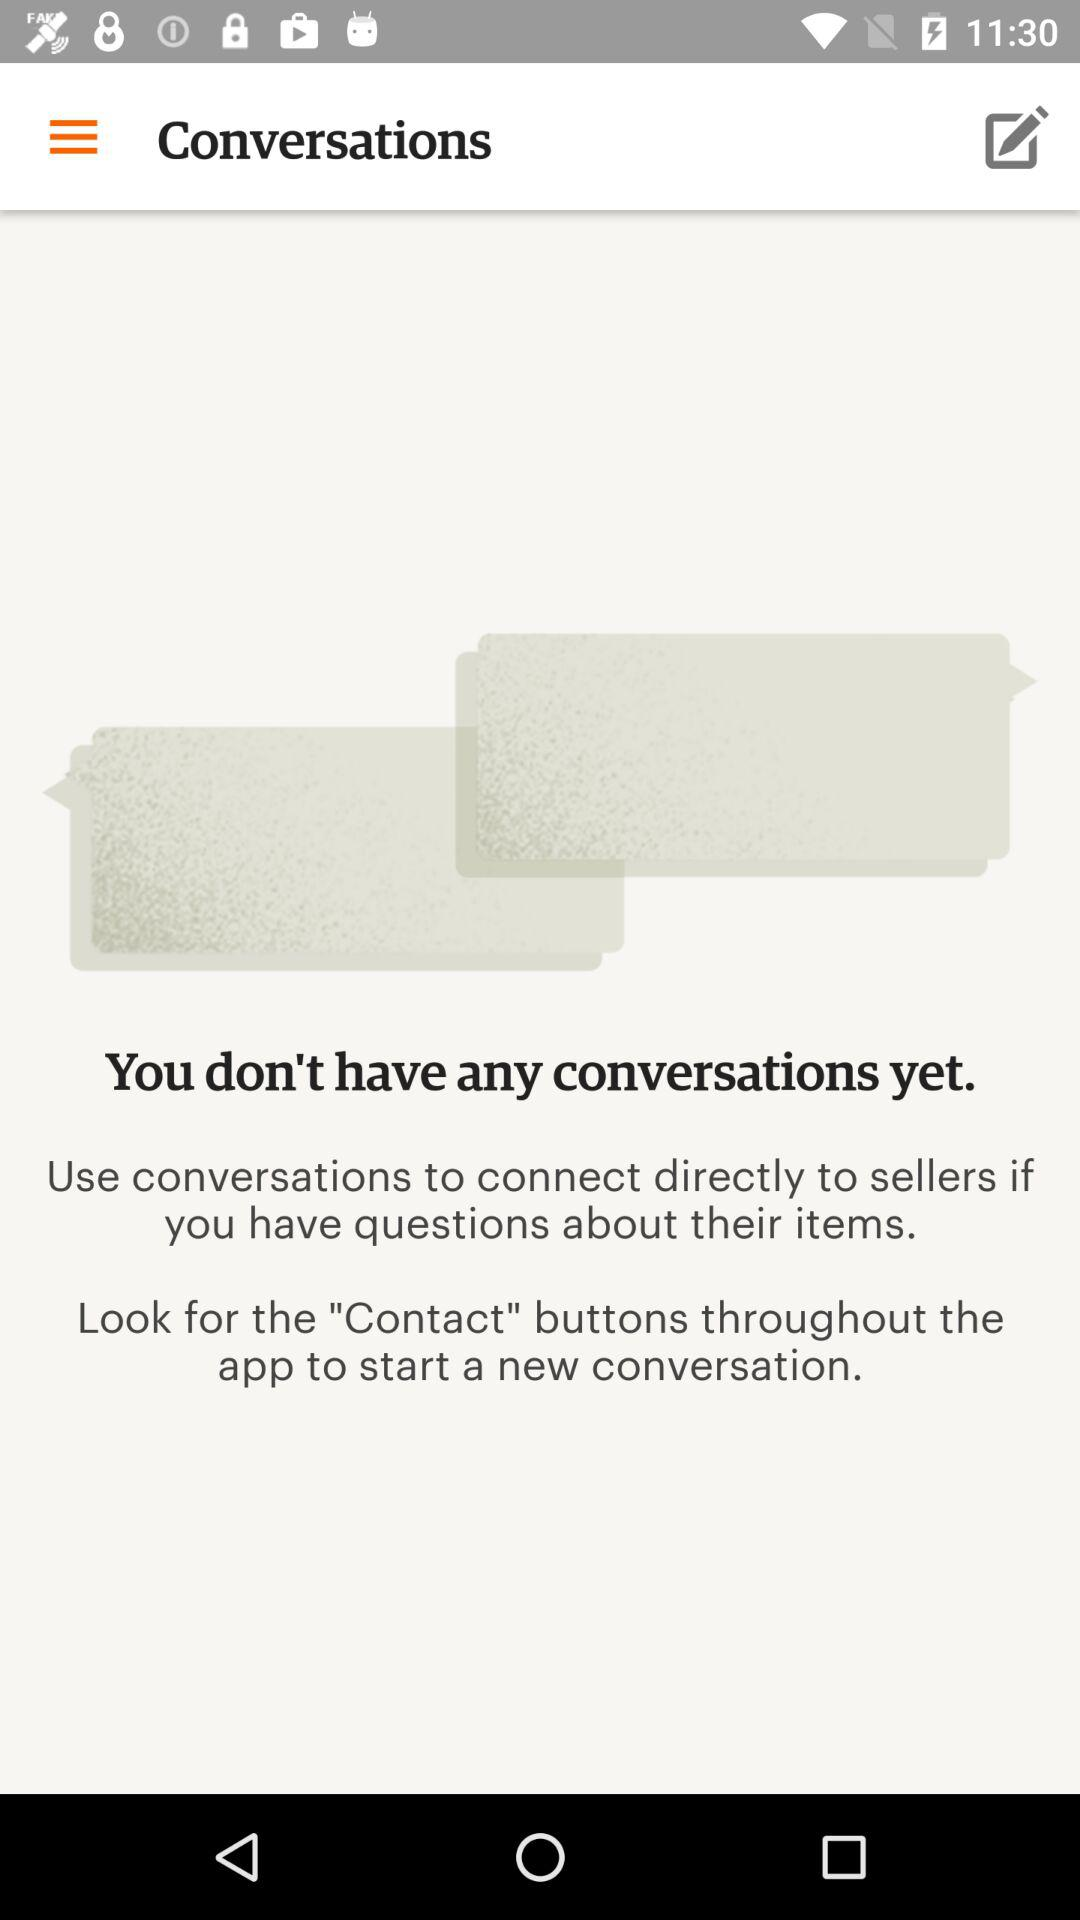Is there any conversation? There is no conversation. 